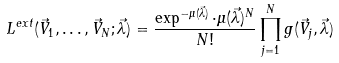<formula> <loc_0><loc_0><loc_500><loc_500>L ^ { e x t } ( \vec { V } _ { 1 } , \dots , \vec { V } _ { N } ; \vec { \lambda } ) = \frac { \exp ^ { - \mu ( \vec { \lambda } ) } \cdot \mu ( \vec { \lambda } ) ^ { N } } { N ! } \prod _ { j = 1 } ^ { N } g ( \vec { V } _ { j } , \vec { \lambda } )</formula> 